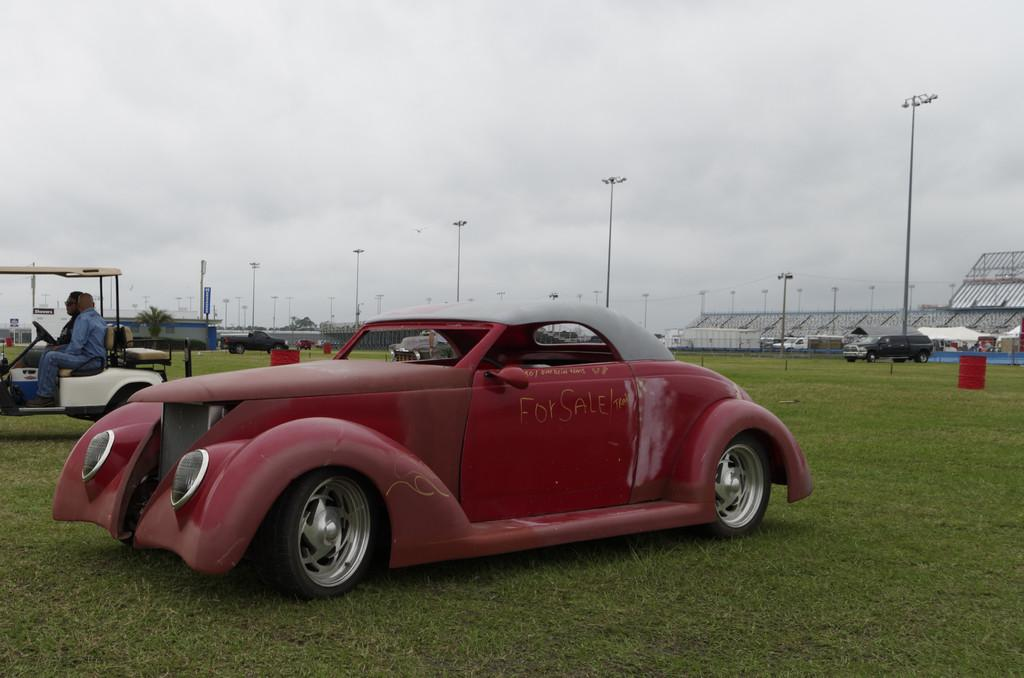What types of objects are present in the image? There are vehicles, people, lights, buildings, and grass visible in the image. Can you describe the setting of the image? The image features vehicles, people, lights, and buildings, which suggests an urban or city setting. The presence of grass also indicates that there might be some green spaces or parks nearby. What is visible at the top of the image? The sky is visible at the top of the image. How many apples are being used to make the pan in the image? There are no apples or pans present in the image. Can you tell me who made the request for more apples in the image? There is no mention of a request or apples in the image. 